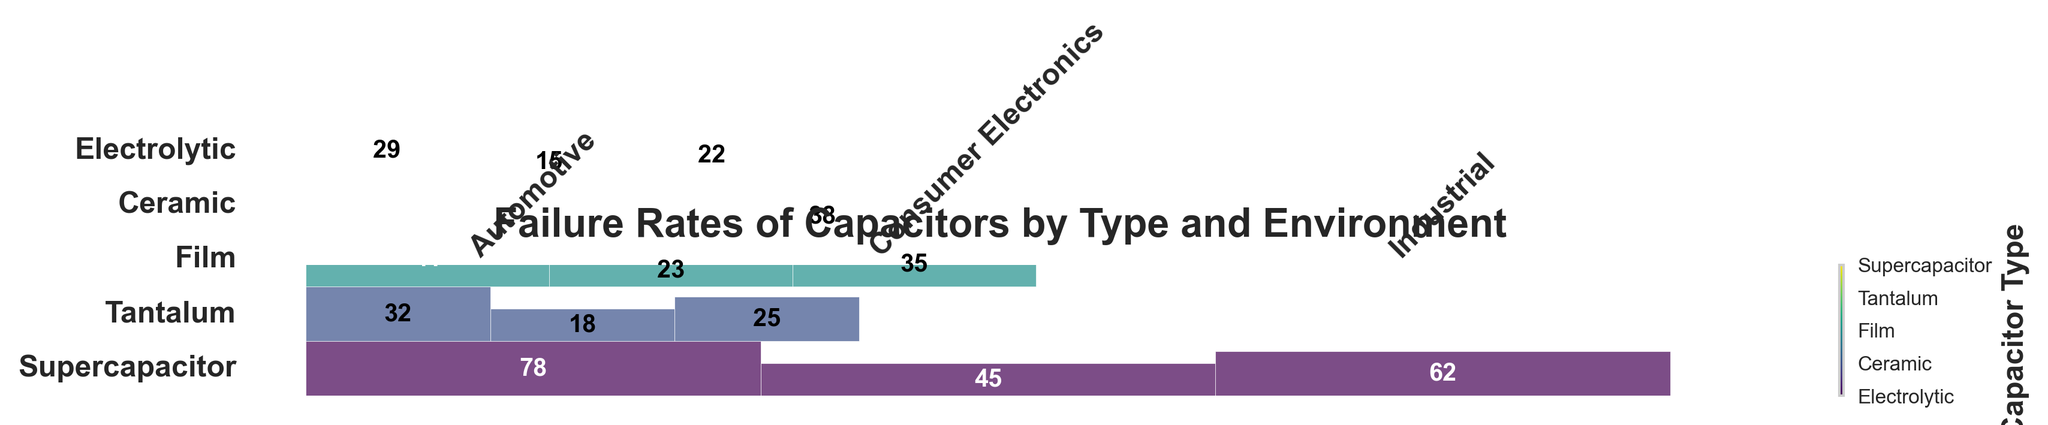What is the title of the figure? The title of the figure is located at the top center. It is plain text styled to provide a clear description of the plot's content.
Answer: Failure Rates of Capacitors by Type and Environment Which capacitor type has the highest failure rate in an automotive environment? Locate the blocks corresponding to the automotive environment and compare the failure rates. The block with the highest failure rate will be for the Electrolytic capacitor.
Answer: Electrolytic What is the failure rate of ceramic capacitors in consumer electronics? Locate the section of the mosaic plot for ceramic capacitors and find the specific failure rate for consumer electronics within that section.
Answer: 18 Compare the failure rates of electrolytic and supercapacitor types in industrial environments. Which one is higher? Find the blocks for both electrolytic and supercapacitor types under the industrial environment. Compare their heights to determine which is higher.
Answer: Electrolytic What is the difference in failure rates between film capacitors and tantalum capacitors in consumer electronics? Find the two specific blocks for film and tantalum capacitors in consumer electronics. Subtract the failure rate of film capacitors from tantalum capacitors.
Answer: 15 How are the capacitor types represented visually in the figure? Each type of capacitor is represented by a different color within the mosaic plot. This is visible in the plot's color legend.
Answer: Different colors Which environment has the lowest failure rate for supercapacitors? Look at the sections within the supercapacitor blocks for each environment and determine which one has the smallest block height.
Answer: Consumer Electronics What is the total failure rate for film capacitors across all environments? Add up the failure rates for film capacitors in automotive, consumer electronics, and industrial environments: 41 + 23 + 35.
Answer: 99 Are there more blocks with a failure rate greater than 40 or less than/equal to 40? Count the number of blocks with failure rates greater than 40 and those with rates less than or equal to 40 from all environments and capacitor types.
Answer: Greater than 40 What is the proportion of failure rates in automotive environments compared to consumer electronics for tantalum capacitors? Divide the failure rate of tantalum capacitors in the automotive environment by that in the consumer electronics environment: 55 / 38.
Answer: 1.45 